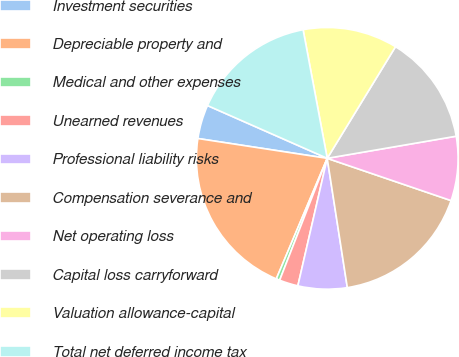Convert chart. <chart><loc_0><loc_0><loc_500><loc_500><pie_chart><fcel>Investment securities<fcel>Depreciable property and<fcel>Medical and other expenses<fcel>Unearned revenues<fcel>Professional liability risks<fcel>Compensation severance and<fcel>Net operating loss<fcel>Capital loss carryforward<fcel>Valuation allowance-capital<fcel>Total net deferred income tax<nl><fcel>4.19%<fcel>21.06%<fcel>0.44%<fcel>2.32%<fcel>6.06%<fcel>17.31%<fcel>7.94%<fcel>13.56%<fcel>11.69%<fcel>15.44%<nl></chart> 